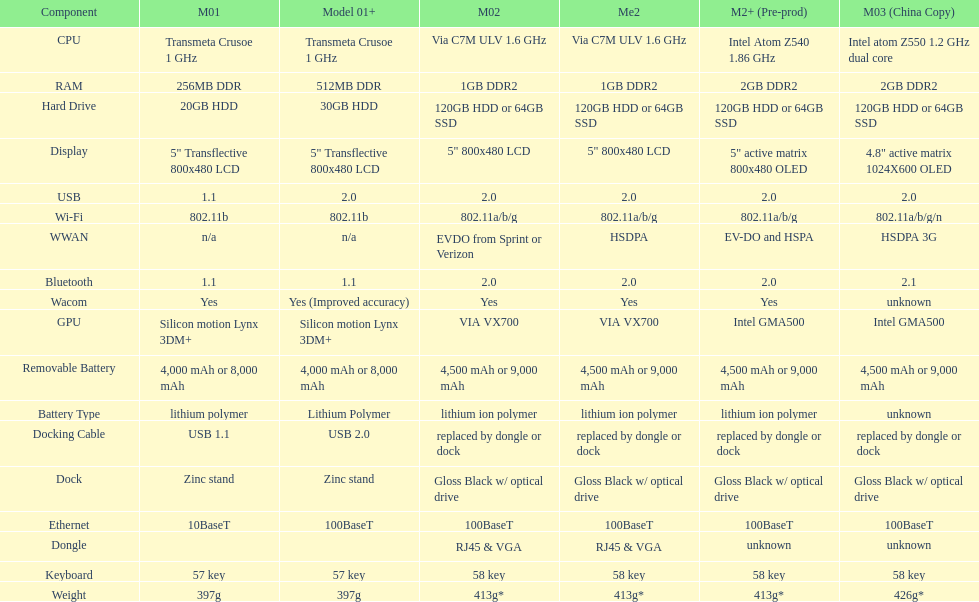What is the average number of models that have usb 2.0? 5. 